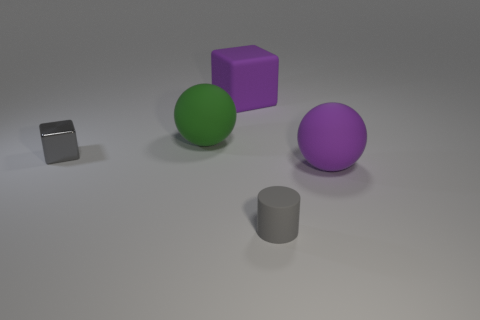Add 4 large green matte spheres. How many objects exist? 9 Subtract all cylinders. How many objects are left? 4 Subtract all purple things. Subtract all tiny metal objects. How many objects are left? 2 Add 3 gray shiny cubes. How many gray shiny cubes are left? 4 Add 1 purple rubber spheres. How many purple rubber spheres exist? 2 Subtract 0 blue cylinders. How many objects are left? 5 